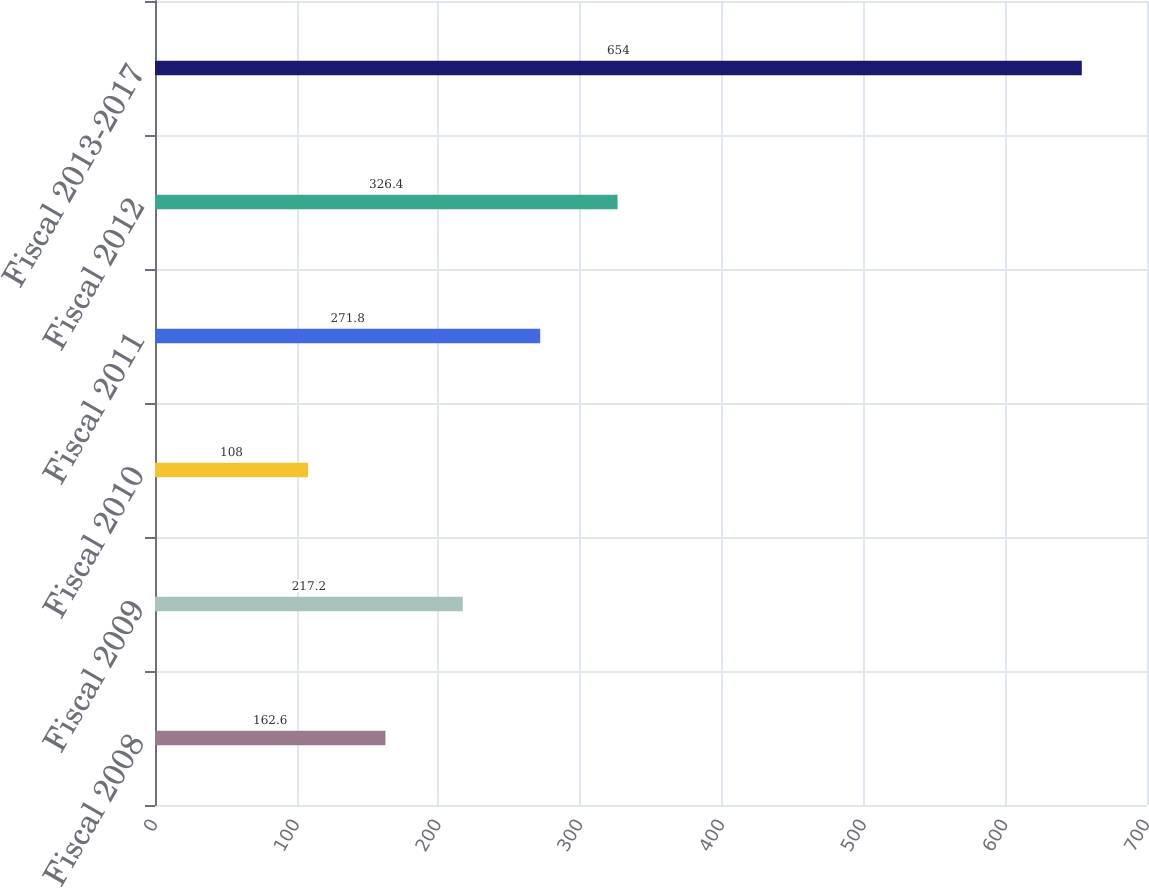Convert chart to OTSL. <chart><loc_0><loc_0><loc_500><loc_500><bar_chart><fcel>Fiscal 2008<fcel>Fiscal 2009<fcel>Fiscal 2010<fcel>Fiscal 2011<fcel>Fiscal 2012<fcel>Fiscal 2013-2017<nl><fcel>162.6<fcel>217.2<fcel>108<fcel>271.8<fcel>326.4<fcel>654<nl></chart> 